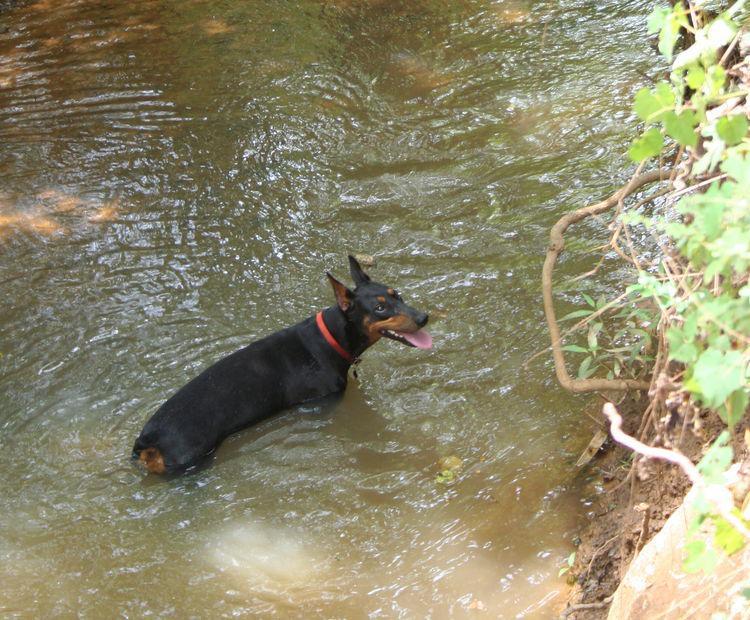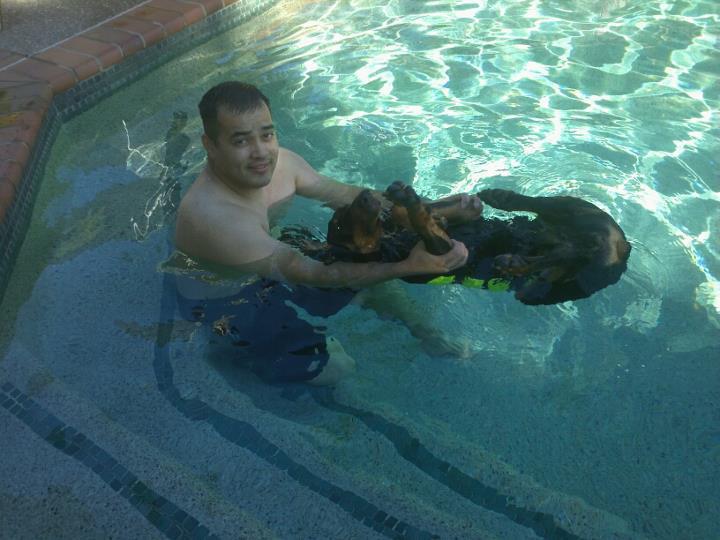The first image is the image on the left, the second image is the image on the right. For the images shown, is this caption "Both dogs are swimming in a pool and neither is sitting on a float." true? Answer yes or no. No. The first image is the image on the left, the second image is the image on the right. Assess this claim about the two images: "A man is in a pool interacting with a doberman in one image, and the other shows a doberman by itself in water.". Correct or not? Answer yes or no. Yes. 